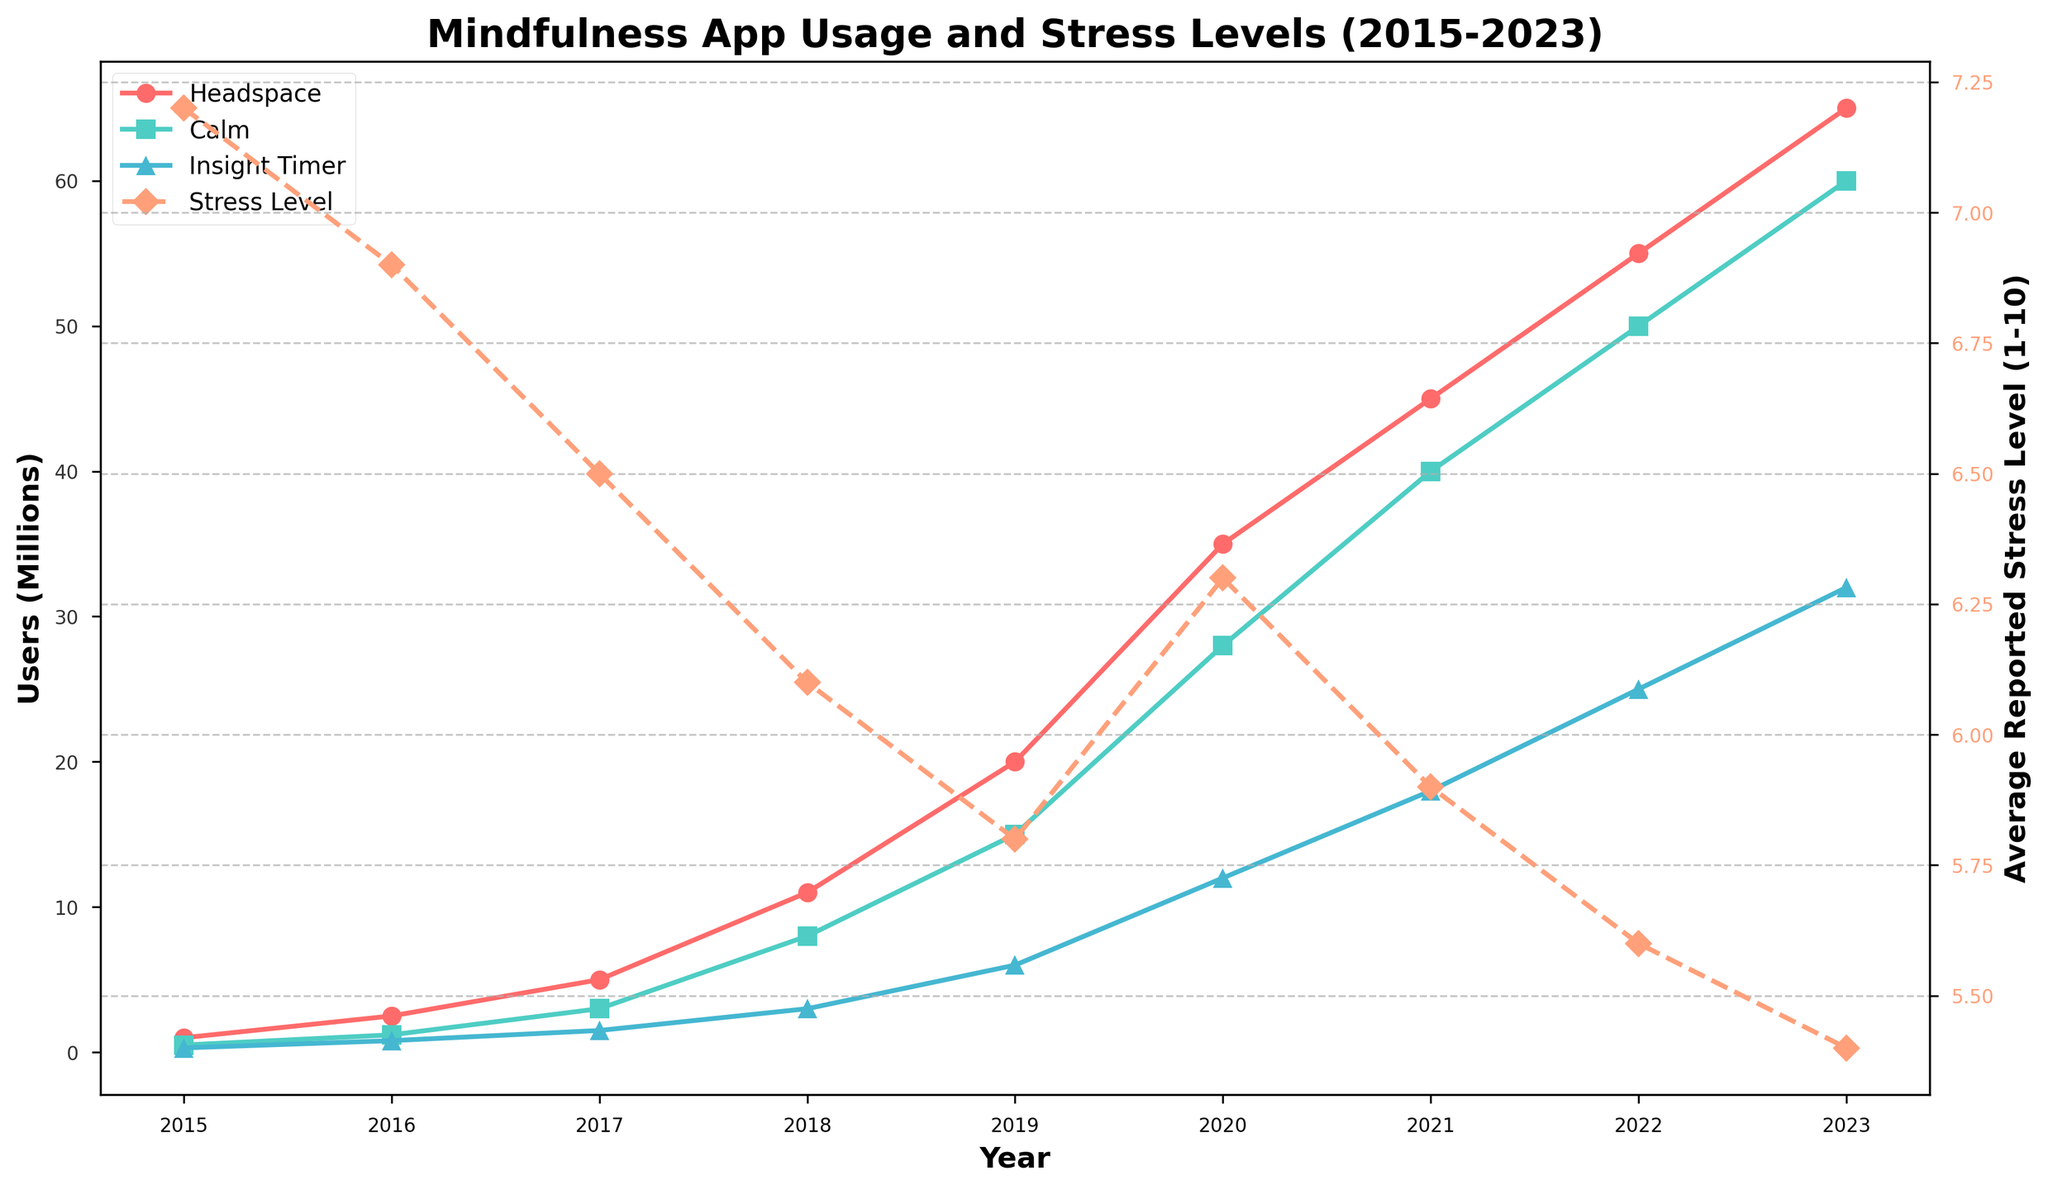Which app had the highest number of users in 2023? By examining the lines on the chart for the year 2023, we see that Headspace had the highest number of users compared to Calm and Insight Timer.
Answer: Headspace Between which years did Calm see its largest growth in users? Looking at the rise in the Calm users' line, the largest increase seems to occur between 2017 and 2018.
Answer: 2017-2018 How did the average reported stress level change between 2019 and 2020? Checking the average reported stress level line, we see it increased from 2019 (5.8) to 2020 (6.3).
Answer: Increased By how much did the combined number of users for Headspace, Calm, and Insight Timer increase from 2018 to 2023? The numbers for 2018 are Headspace: 11M, Calm: 8M, Insight Timer: 3M, totaling 22M. For 2023, these numbers are 65M, 60M, and 32M, totaling 157M. The increase is 157M - 22M = 135M.
Answer: 135M Which year showed a decrease in average reported stress level after an initial increase from the year before? Observe the stress level line which increased from 2019 (5.8) to 2020 (6.3), then decreased in 2021 (5.9).
Answer: 2021 Which app saw the smallest increase in users from 2018 to 2019? Headspace increased from 11M to 20M (9M increase), Calm from 8M to 15M (7M increase), and Insight Timer from 3M to 6M (3M increase). Insight Timer had the smallest increase.
Answer: Insight Timer What is the general trend in average reported stress levels over the years? The stress level line generally shows a downward trend from 2015 to 2023, despite a slight increase in 2020.
Answer: Decreasing Compare the number of users for Insight Timer in 2015 and 2017. From the chart, Insight Timer users were 300,000 in 2015 and 1,500,000 in 2017. We see an increase in users.
Answer: Increased 